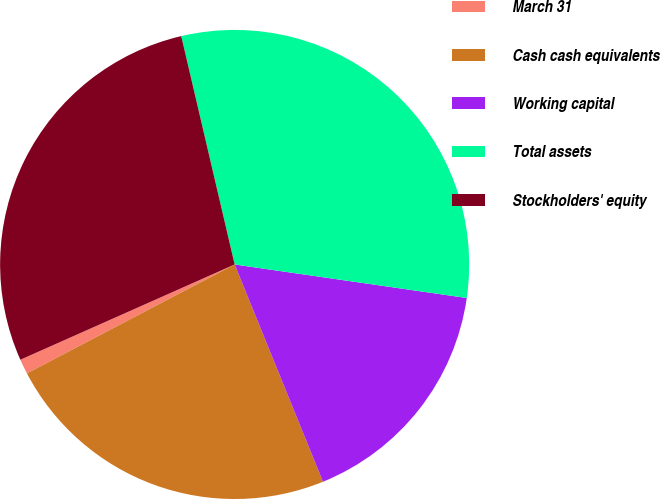<chart> <loc_0><loc_0><loc_500><loc_500><pie_chart><fcel>March 31<fcel>Cash cash equivalents<fcel>Working capital<fcel>Total assets<fcel>Stockholders' equity<nl><fcel>1.03%<fcel>23.46%<fcel>16.57%<fcel>30.94%<fcel>28.0%<nl></chart> 